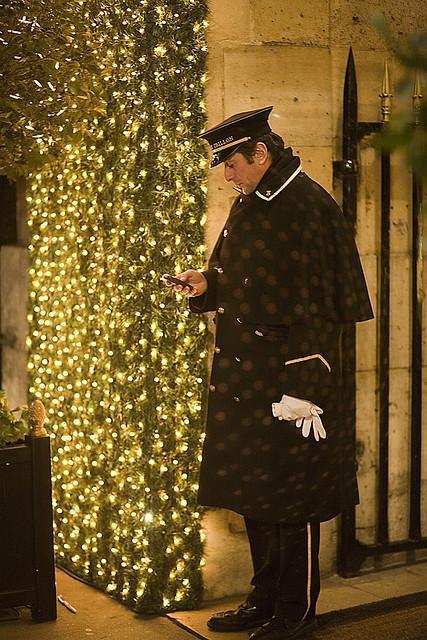How many dogs are there left to the lady?
Give a very brief answer. 0. 